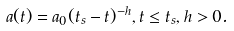<formula> <loc_0><loc_0><loc_500><loc_500>a ( t ) = a _ { 0 } ( t _ { s } - t ) ^ { - h } , t \leq t _ { s } , h > 0 .</formula> 